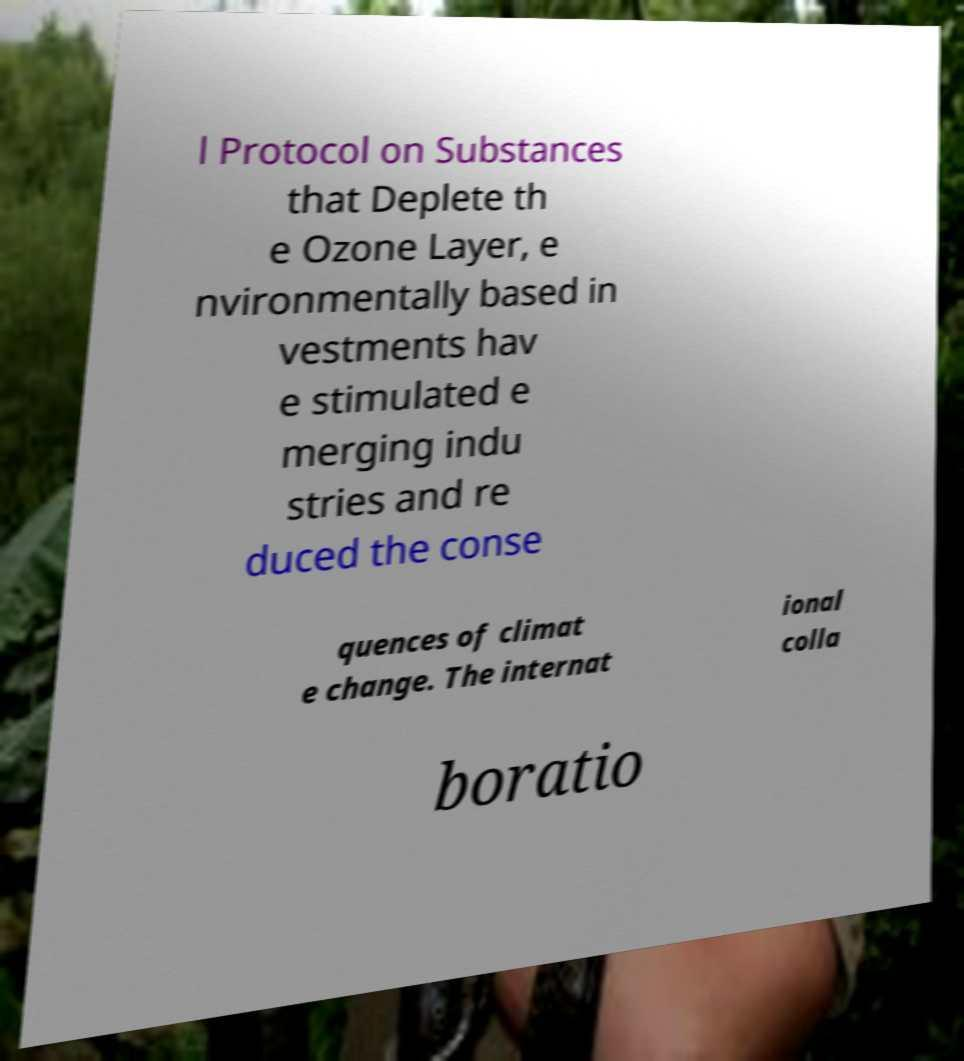Can you accurately transcribe the text from the provided image for me? l Protocol on Substances that Deplete th e Ozone Layer, e nvironmentally based in vestments hav e stimulated e merging indu stries and re duced the conse quences of climat e change. The internat ional colla boratio 